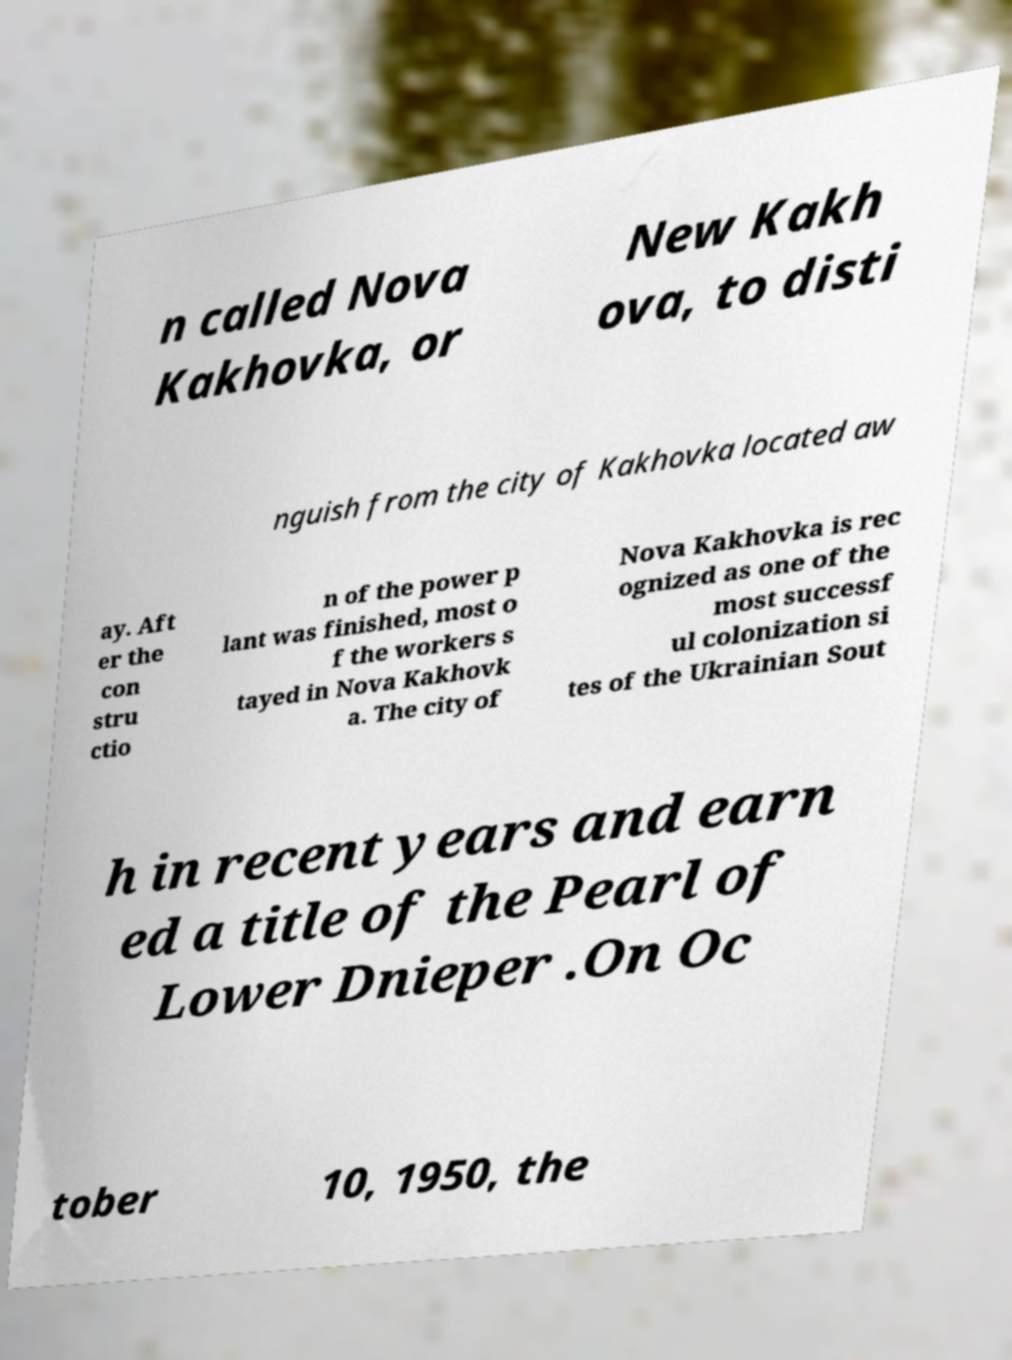Could you extract and type out the text from this image? n called Nova Kakhovka, or New Kakh ova, to disti nguish from the city of Kakhovka located aw ay. Aft er the con stru ctio n of the power p lant was finished, most o f the workers s tayed in Nova Kakhovk a. The city of Nova Kakhovka is rec ognized as one of the most successf ul colonization si tes of the Ukrainian Sout h in recent years and earn ed a title of the Pearl of Lower Dnieper .On Oc tober 10, 1950, the 